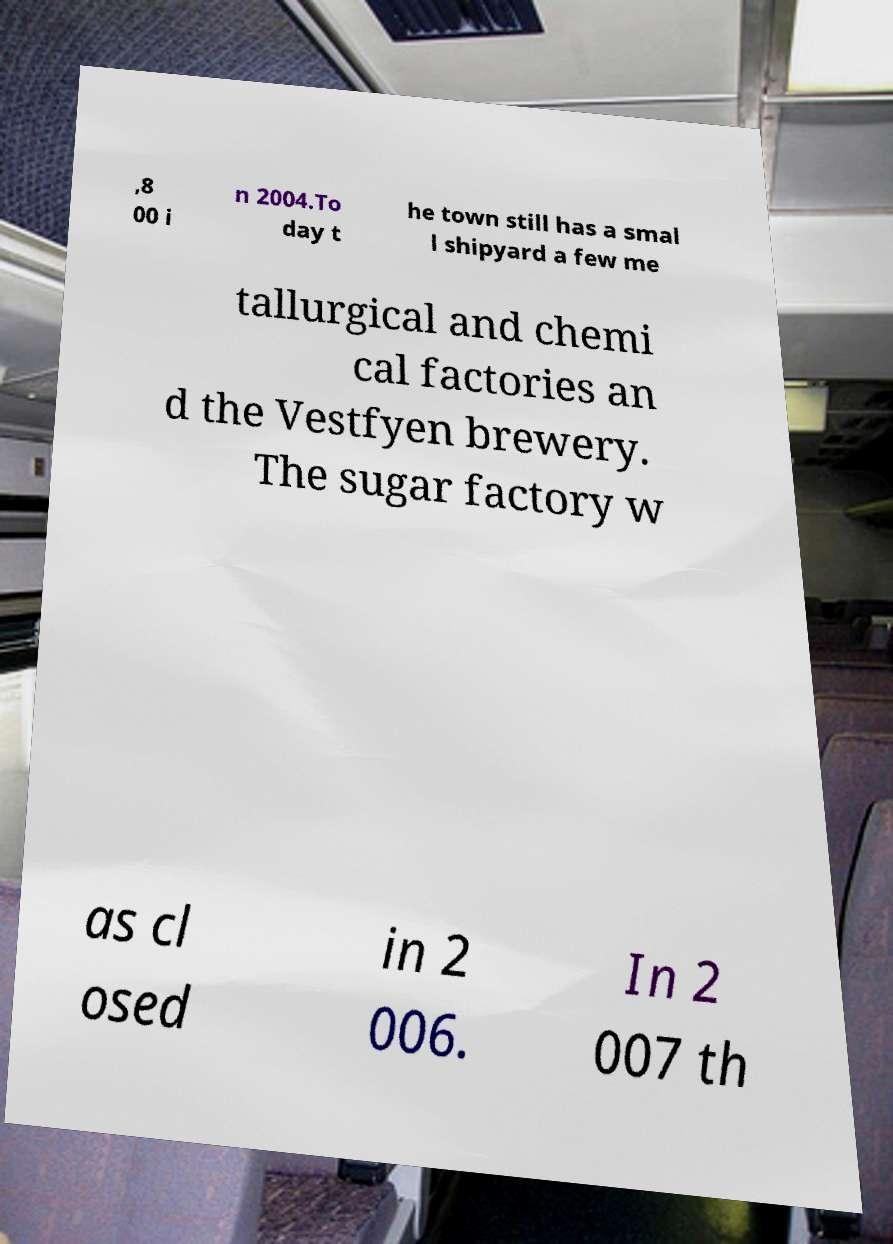Please read and relay the text visible in this image. What does it say? ,8 00 i n 2004.To day t he town still has a smal l shipyard a few me tallurgical and chemi cal factories an d the Vestfyen brewery. The sugar factory w as cl osed in 2 006. In 2 007 th 